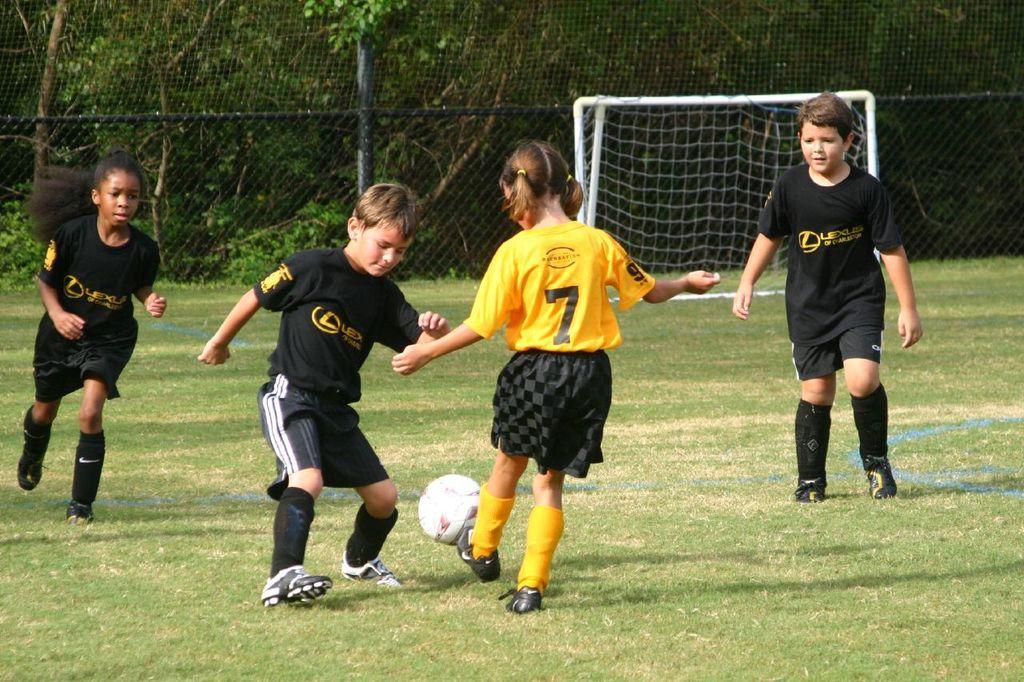Can you describe this image briefly? This picture is clicked outside which is in the play ground. On the right there is a Boy wearing a black color t-shirt, looking at the ball and walking. In the center there is a Girl wearing a yellow t-shirt and a Boy wearing a black color t-shirt, both of them are trying to kick the ball. On the left there is a Girl wearing a black color t-shirt and running. In the background there is a football net, many number of Trees and some Plants. 